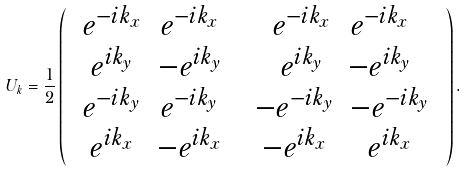<formula> <loc_0><loc_0><loc_500><loc_500>U _ { k } = \frac { 1 } { 2 } \left ( \begin{array} { c c } \begin{array} { c c } e ^ { - i k _ { x } } & e ^ { - i k _ { x } } \\ e ^ { i k _ { y } } & - e ^ { i k _ { y } } \end{array} & \begin{array} { c c } e ^ { - i k _ { x } } & e ^ { - i k _ { x } } \\ e ^ { i k _ { y } } & { - e } ^ { i k _ { y } } \end{array} \\ \begin{array} { c c } e ^ { - i k _ { y } } & e ^ { - i k _ { y } } \\ e ^ { i k _ { x } } & - e ^ { i k _ { x } } \end{array} & \begin{array} { c c } { - e } ^ { - i k _ { y } } & { - e } ^ { - i k _ { y } } \\ - e ^ { i k _ { x } } & e ^ { i k _ { x } } \end{array} \end{array} \right ) .</formula> 